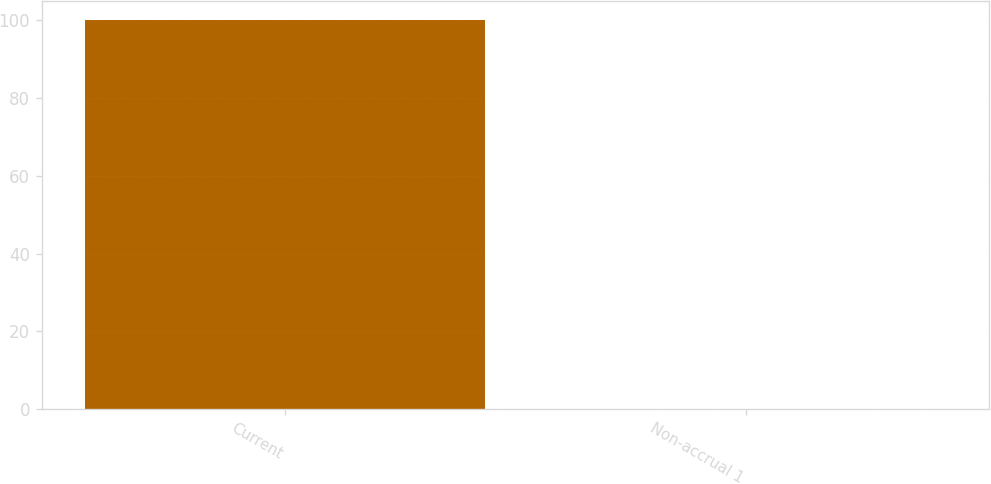Convert chart to OTSL. <chart><loc_0><loc_0><loc_500><loc_500><bar_chart><fcel>Current<fcel>Non-accrual 1<nl><fcel>99.9<fcel>0.1<nl></chart> 